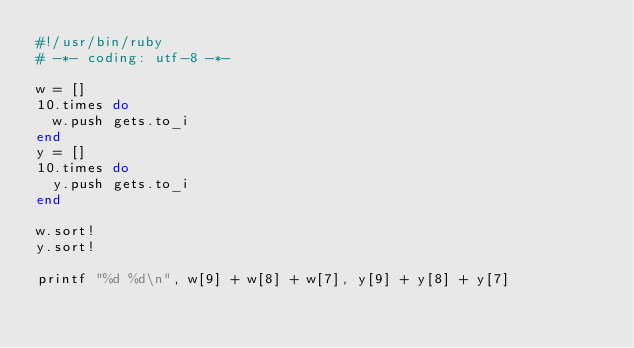<code> <loc_0><loc_0><loc_500><loc_500><_Ruby_>#!/usr/bin/ruby
# -*- coding: utf-8 -*-

w = []
10.times do
  w.push gets.to_i
end
y = []
10.times do
  y.push gets.to_i
end

w.sort!
y.sort!

printf "%d %d\n", w[9] + w[8] + w[7], y[9] + y[8] + y[7]
                 </code> 